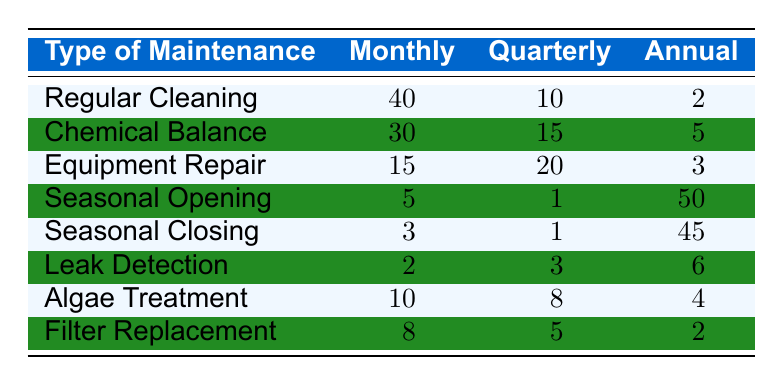What's the total number of monthly service requests for Regular Cleaning? The table shows that Regular Cleaning has 40 monthly requests listed.
Answer: 40 How many annual requests are there for Seasonal Closing? The table indicates that there are 45 annual requests for Seasonal Closing.
Answer: 45 Which type of maintenance has the highest number of quarterly requests? By comparing the quarterly requests, Equipment Repair has 20, while the next highest is Chemical Balance with 15. Therefore, Equipment Repair has the highest quarterly requests.
Answer: Equipment Repair How many total service requests (monthly + quarterly + annual) are there for Chemical Balance? The total is calculated as 30 (monthly) + 15 (quarterly) + 5 (annual) = 50.
Answer: 50 Which type of maintenance sees the least monthly requests? Comparing the monthly requests, Seasonal Closing has only 3 monthly requests, which is fewer than any other type.
Answer: Seasonal Closing Is there a type of maintenance that has more annual requests than monthly requests? Yes, both Seasonal Opening (50 annual vs. 5 monthly) and Seasonal Closing (45 annual vs. 3 monthly) have more annual requests than monthly requests.
Answer: Yes What is the average number of monthly service requests across all maintenance types? Summing all monthly requests gives us (40 + 30 + 15 + 5 + 3 + 2 + 10 + 8) = 113. Dividing by the 8 types results in an average of 113 / 8 = 14.125.
Answer: 14.125 How many requests are there in total for Leak Detection? Leak Detection has 2 monthly, 3 quarterly, and 6 annual requests, summing them gives 2 + 3 + 6 = 11.
Answer: 11 Identify the maintenance type which has both monthly and annual requests less than 5. The only type that fulfills this condition is Leak Detection, which has 2 monthly and 6 annual requests but no type has both lower than 5 in both categories.
Answer: None What is the combined number of quarterly and annual requests for Algae Treatment? The calculation involves summing up Algae Treatment's quarterly requests (8) and annual requests (4), giving us a total of 8 + 4 = 12.
Answer: 12 Which maintenance type has the greatest disparity between monthly and annual requests? Seasonal Opening has 5 monthly requests and 50 annual requests. The disparity is 50 - 5 = 45. This is greater than any other maintenance type.
Answer: Seasonal Opening 